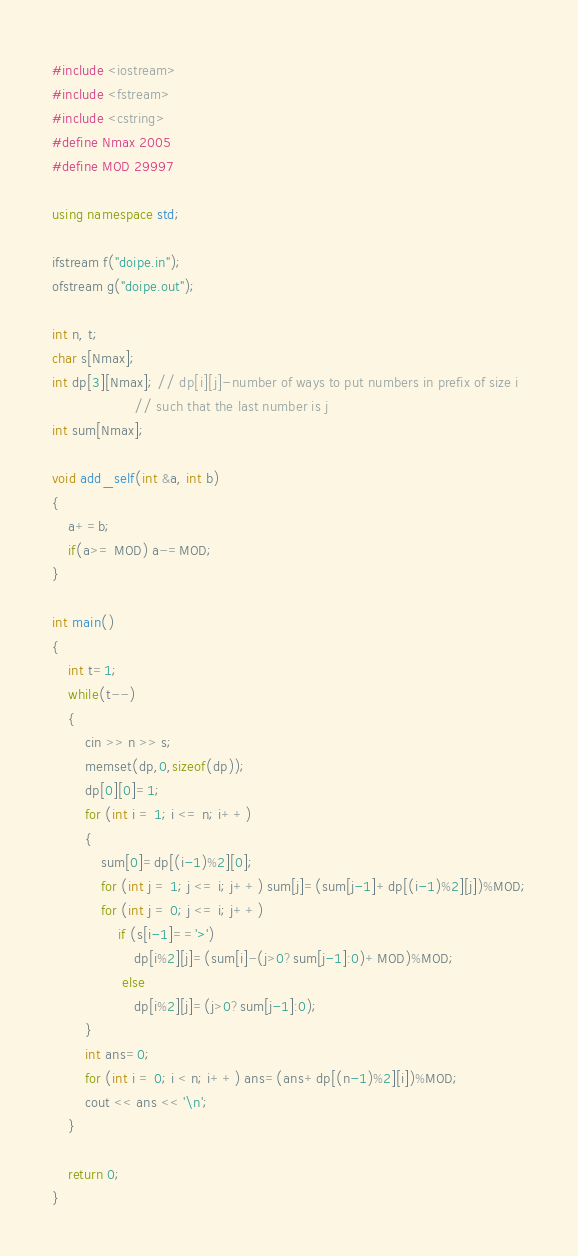Convert code to text. <code><loc_0><loc_0><loc_500><loc_500><_C++_>#include <iostream>
#include <fstream>
#include <cstring>
#define Nmax 2005
#define MOD 29997

using namespace std;

ifstream f("doipe.in");
ofstream g("doipe.out");

int n, t;
char s[Nmax];
int dp[3][Nmax]; // dp[i][j]-number of ways to put numbers in prefix of size i
                    // such that the last number is j
int sum[Nmax];

void add_self(int &a, int b)
{
    a+=b;
    if(a>= MOD) a-=MOD;
}

int main()
{
    int t=1;
    while(t--)
    {
        cin >> n >> s;
        memset(dp,0,sizeof(dp));
        dp[0][0]=1;
        for (int i = 1; i <= n; i++)
        {
            sum[0]=dp[(i-1)%2][0];
            for (int j = 1; j <= i; j++) sum[j]=(sum[j-1]+dp[(i-1)%2][j])%MOD;
            for (int j = 0; j <= i; j++)
                if (s[i-1]=='>')
                    dp[i%2][j]=(sum[i]-(j>0?sum[j-1]:0)+MOD)%MOD;
                 else
                    dp[i%2][j]=(j>0?sum[j-1]:0);
        }
        int ans=0;
        for (int i = 0; i < n; i++) ans=(ans+dp[(n-1)%2][i])%MOD;
        cout << ans << '\n';
    }

    return 0;
}

</code> 